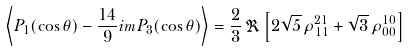<formula> <loc_0><loc_0><loc_500><loc_500>\left \langle P _ { 1 } ( \cos \theta ) - \frac { 1 4 } { 9 } \sl i m P _ { 3 } ( \cos \theta ) \right \rangle = \frac { 2 } { 3 } \, \Re \left [ 2 \sqrt { 5 } \, \rho _ { 1 1 } ^ { 2 1 } + \sqrt { 3 } \, \rho _ { 0 0 } ^ { 1 0 } \right ]</formula> 